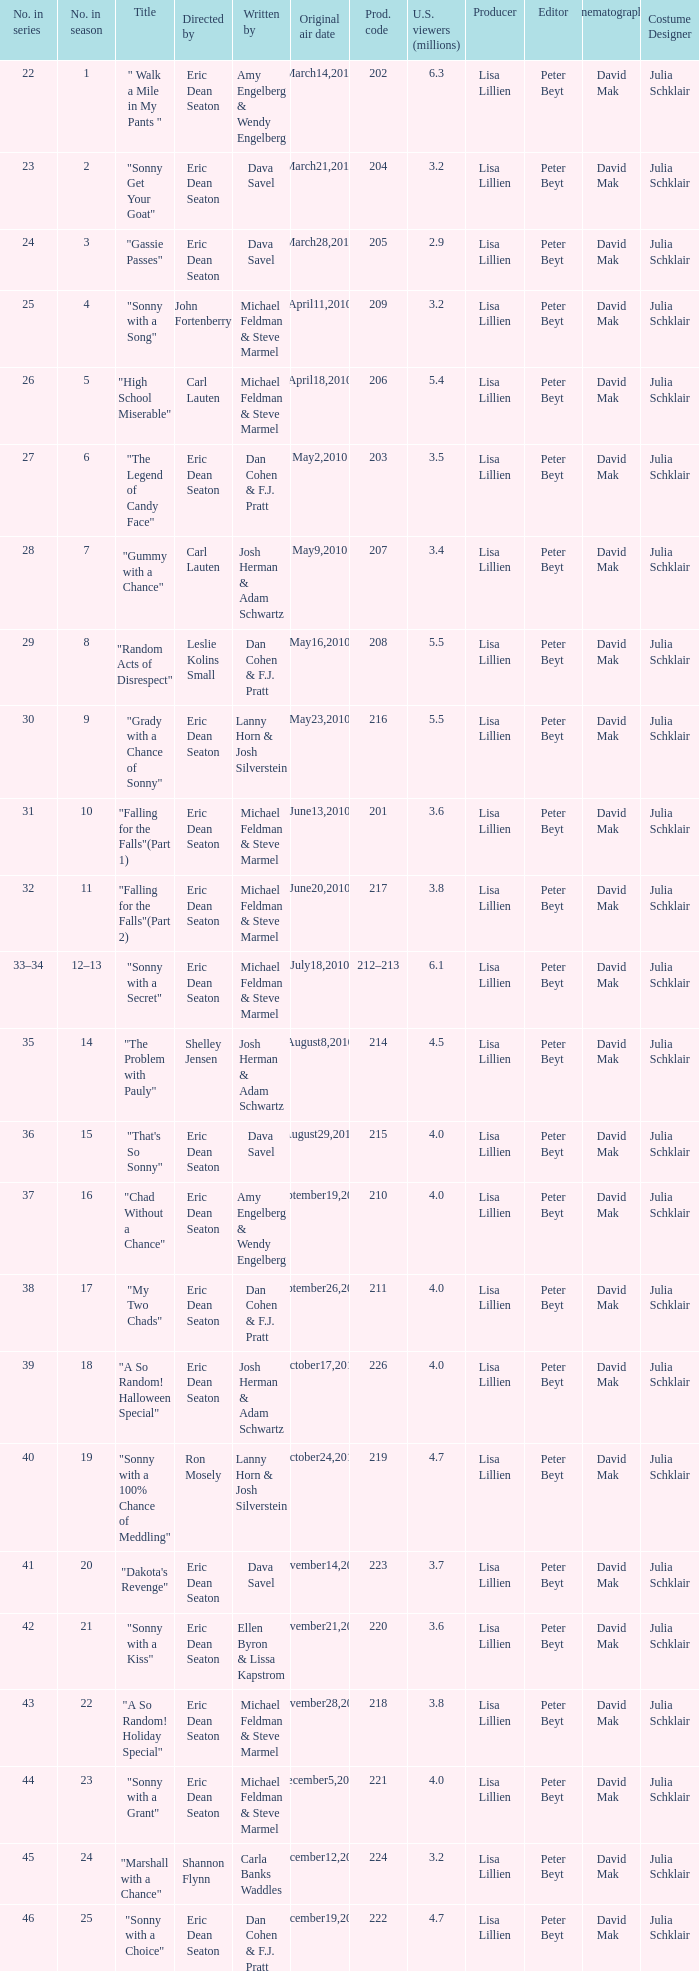Who directed the episode that 6.3 million u.s. viewers saw? Eric Dean Seaton. 